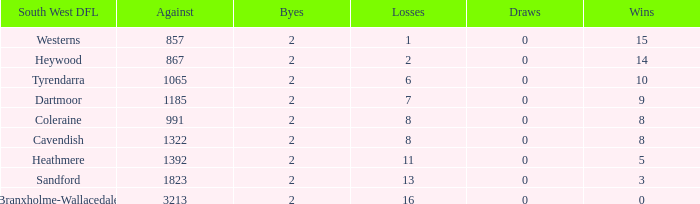Which draws have an average of 14 wins? 0.0. 